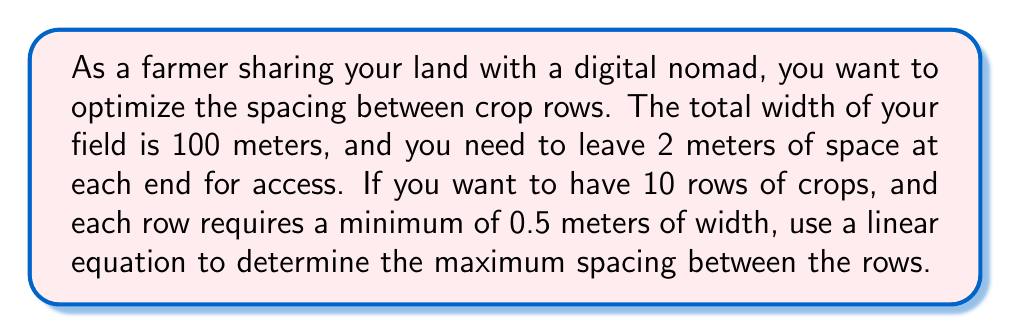Can you answer this question? Let's approach this step-by-step:

1) Let $x$ be the spacing between rows in meters.

2) We know that:
   - The total width of the field is 100 meters
   - We need 2 meters of space at each end, so 4 meters in total
   - We want 10 rows of crops
   - Each row requires a minimum of 0.5 meters of width

3) Let's set up our equation:
   $$(10 \times 0.5) + (9 \times x) + 4 = 100$$

   Here's what each part means:
   - $(10 \times 0.5)$ is the total width of the crop rows
   - $(9 \times x)$ is the total spacing between the rows (there are 9 spaces between 10 rows)
   - $4$ is the total space at the ends
   - $100$ is the total width of the field

4) Simplify the left side of the equation:
   $$5 + 9x + 4 = 100$$
   $$9x + 9 = 100$$

5) Subtract 9 from both sides:
   $$9x = 91$$

6) Divide both sides by 9:
   $$x = \frac{91}{9} = 10.11111...$$ 

Therefore, the maximum spacing between rows is approximately 10.11 meters.
Answer: $10.11$ meters 